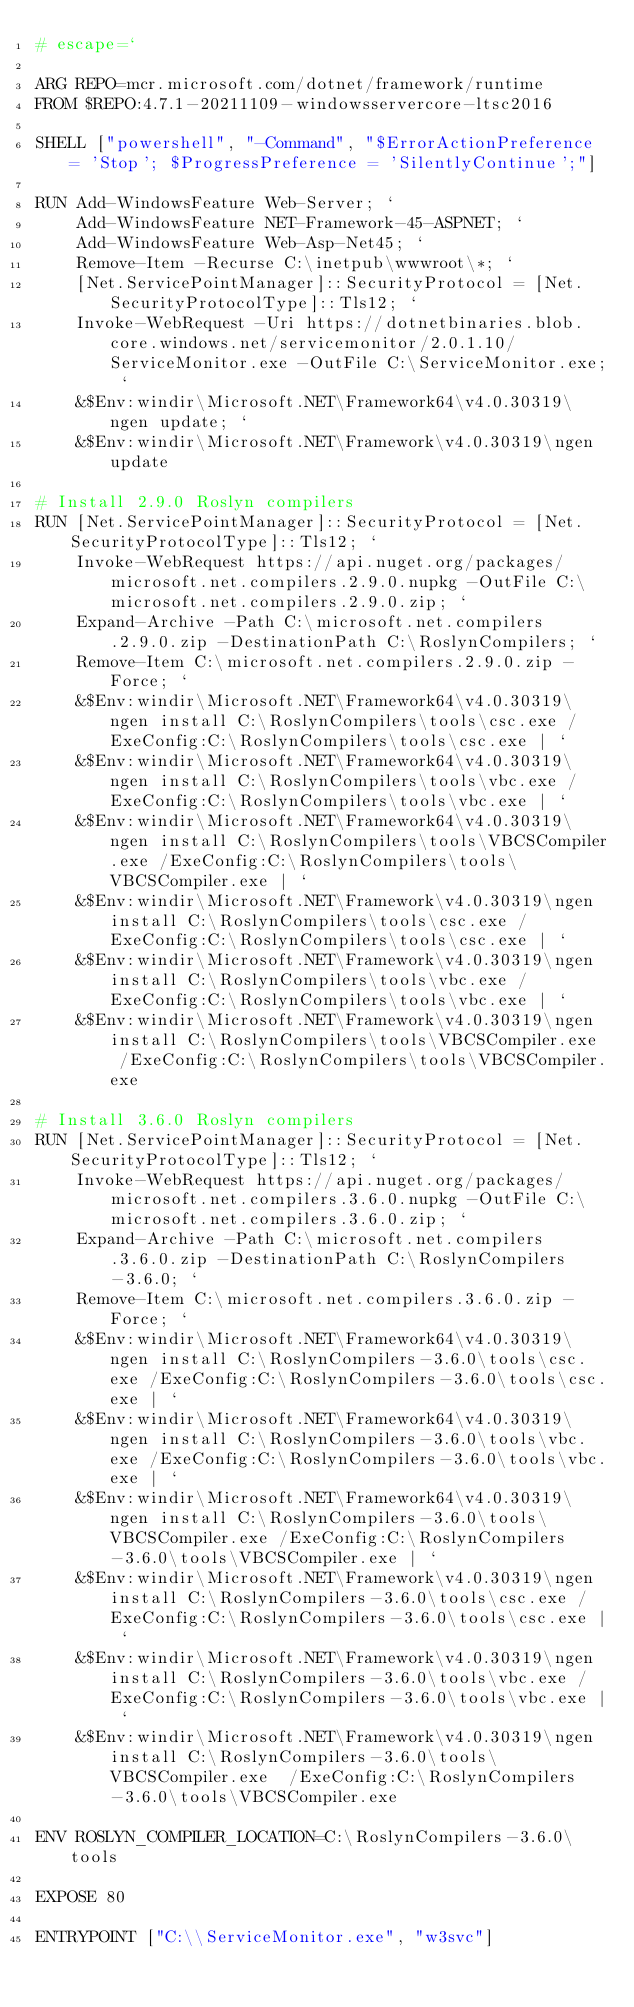<code> <loc_0><loc_0><loc_500><loc_500><_Dockerfile_># escape=`

ARG REPO=mcr.microsoft.com/dotnet/framework/runtime
FROM $REPO:4.7.1-20211109-windowsservercore-ltsc2016

SHELL ["powershell", "-Command", "$ErrorActionPreference = 'Stop'; $ProgressPreference = 'SilentlyContinue';"]

RUN Add-WindowsFeature Web-Server; `
    Add-WindowsFeature NET-Framework-45-ASPNET; `
    Add-WindowsFeature Web-Asp-Net45; `
    Remove-Item -Recurse C:\inetpub\wwwroot\*; `
    [Net.ServicePointManager]::SecurityProtocol = [Net.SecurityProtocolType]::Tls12; `
    Invoke-WebRequest -Uri https://dotnetbinaries.blob.core.windows.net/servicemonitor/2.0.1.10/ServiceMonitor.exe -OutFile C:\ServiceMonitor.exe; `
    &$Env:windir\Microsoft.NET\Framework64\v4.0.30319\ngen update; `
    &$Env:windir\Microsoft.NET\Framework\v4.0.30319\ngen update

# Install 2.9.0 Roslyn compilers
RUN [Net.ServicePointManager]::SecurityProtocol = [Net.SecurityProtocolType]::Tls12; `
    Invoke-WebRequest https://api.nuget.org/packages/microsoft.net.compilers.2.9.0.nupkg -OutFile C:\microsoft.net.compilers.2.9.0.zip; `
    Expand-Archive -Path C:\microsoft.net.compilers.2.9.0.zip -DestinationPath C:\RoslynCompilers; `
    Remove-Item C:\microsoft.net.compilers.2.9.0.zip -Force; `
    &$Env:windir\Microsoft.NET\Framework64\v4.0.30319\ngen install C:\RoslynCompilers\tools\csc.exe /ExeConfig:C:\RoslynCompilers\tools\csc.exe | `
    &$Env:windir\Microsoft.NET\Framework64\v4.0.30319\ngen install C:\RoslynCompilers\tools\vbc.exe /ExeConfig:C:\RoslynCompilers\tools\vbc.exe | `
    &$Env:windir\Microsoft.NET\Framework64\v4.0.30319\ngen install C:\RoslynCompilers\tools\VBCSCompiler.exe /ExeConfig:C:\RoslynCompilers\tools\VBCSCompiler.exe | `
    &$Env:windir\Microsoft.NET\Framework\v4.0.30319\ngen install C:\RoslynCompilers\tools\csc.exe /ExeConfig:C:\RoslynCompilers\tools\csc.exe | `
    &$Env:windir\Microsoft.NET\Framework\v4.0.30319\ngen install C:\RoslynCompilers\tools\vbc.exe /ExeConfig:C:\RoslynCompilers\tools\vbc.exe | `
    &$Env:windir\Microsoft.NET\Framework\v4.0.30319\ngen install C:\RoslynCompilers\tools\VBCSCompiler.exe  /ExeConfig:C:\RoslynCompilers\tools\VBCSCompiler.exe

# Install 3.6.0 Roslyn compilers
RUN [Net.ServicePointManager]::SecurityProtocol = [Net.SecurityProtocolType]::Tls12; `
    Invoke-WebRequest https://api.nuget.org/packages/microsoft.net.compilers.3.6.0.nupkg -OutFile C:\microsoft.net.compilers.3.6.0.zip; `
    Expand-Archive -Path C:\microsoft.net.compilers.3.6.0.zip -DestinationPath C:\RoslynCompilers-3.6.0; `
    Remove-Item C:\microsoft.net.compilers.3.6.0.zip -Force; `
    &$Env:windir\Microsoft.NET\Framework64\v4.0.30319\ngen install C:\RoslynCompilers-3.6.0\tools\csc.exe /ExeConfig:C:\RoslynCompilers-3.6.0\tools\csc.exe | `
    &$Env:windir\Microsoft.NET\Framework64\v4.0.30319\ngen install C:\RoslynCompilers-3.6.0\tools\vbc.exe /ExeConfig:C:\RoslynCompilers-3.6.0\tools\vbc.exe | `
    &$Env:windir\Microsoft.NET\Framework64\v4.0.30319\ngen install C:\RoslynCompilers-3.6.0\tools\VBCSCompiler.exe /ExeConfig:C:\RoslynCompilers-3.6.0\tools\VBCSCompiler.exe | `
    &$Env:windir\Microsoft.NET\Framework\v4.0.30319\ngen install C:\RoslynCompilers-3.6.0\tools\csc.exe /ExeConfig:C:\RoslynCompilers-3.6.0\tools\csc.exe | `
    &$Env:windir\Microsoft.NET\Framework\v4.0.30319\ngen install C:\RoslynCompilers-3.6.0\tools\vbc.exe /ExeConfig:C:\RoslynCompilers-3.6.0\tools\vbc.exe | `
    &$Env:windir\Microsoft.NET\Framework\v4.0.30319\ngen install C:\RoslynCompilers-3.6.0\tools\VBCSCompiler.exe  /ExeConfig:C:\RoslynCompilers-3.6.0\tools\VBCSCompiler.exe

ENV ROSLYN_COMPILER_LOCATION=C:\RoslynCompilers-3.6.0\tools

EXPOSE 80

ENTRYPOINT ["C:\\ServiceMonitor.exe", "w3svc"]
</code> 